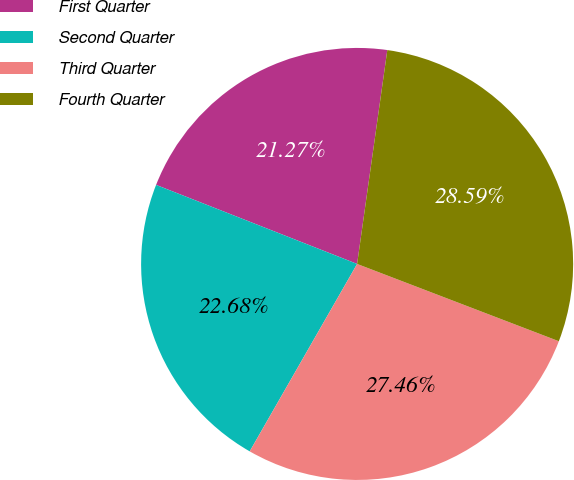<chart> <loc_0><loc_0><loc_500><loc_500><pie_chart><fcel>First Quarter<fcel>Second Quarter<fcel>Third Quarter<fcel>Fourth Quarter<nl><fcel>21.27%<fcel>22.68%<fcel>27.46%<fcel>28.59%<nl></chart> 